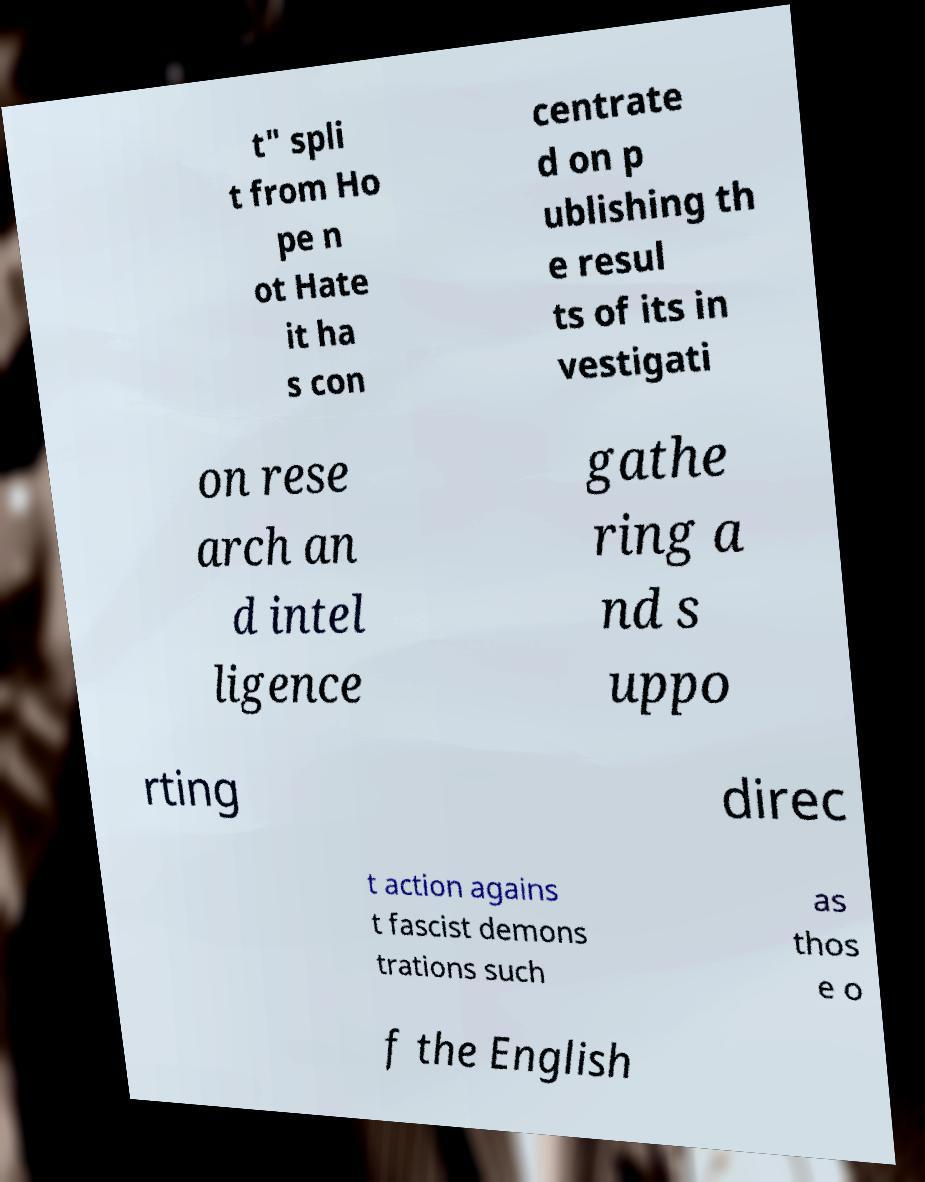I need the written content from this picture converted into text. Can you do that? t" spli t from Ho pe n ot Hate it ha s con centrate d on p ublishing th e resul ts of its in vestigati on rese arch an d intel ligence gathe ring a nd s uppo rting direc t action agains t fascist demons trations such as thos e o f the English 